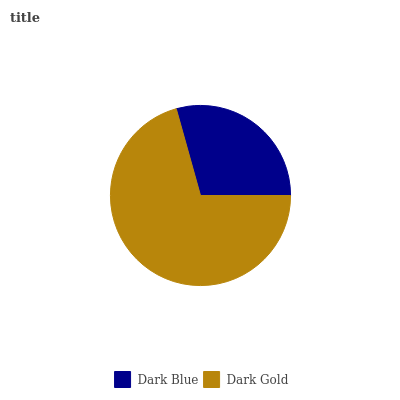Is Dark Blue the minimum?
Answer yes or no. Yes. Is Dark Gold the maximum?
Answer yes or no. Yes. Is Dark Gold the minimum?
Answer yes or no. No. Is Dark Gold greater than Dark Blue?
Answer yes or no. Yes. Is Dark Blue less than Dark Gold?
Answer yes or no. Yes. Is Dark Blue greater than Dark Gold?
Answer yes or no. No. Is Dark Gold less than Dark Blue?
Answer yes or no. No. Is Dark Gold the high median?
Answer yes or no. Yes. Is Dark Blue the low median?
Answer yes or no. Yes. Is Dark Blue the high median?
Answer yes or no. No. Is Dark Gold the low median?
Answer yes or no. No. 